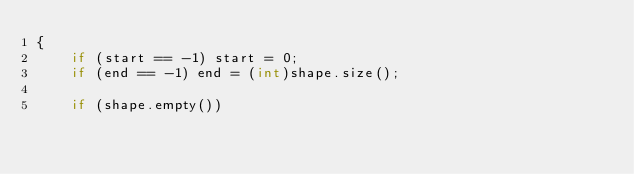<code> <loc_0><loc_0><loc_500><loc_500><_C++_>{
    if (start == -1) start = 0;
    if (end == -1) end = (int)shape.size();

    if (shape.empty())</code> 